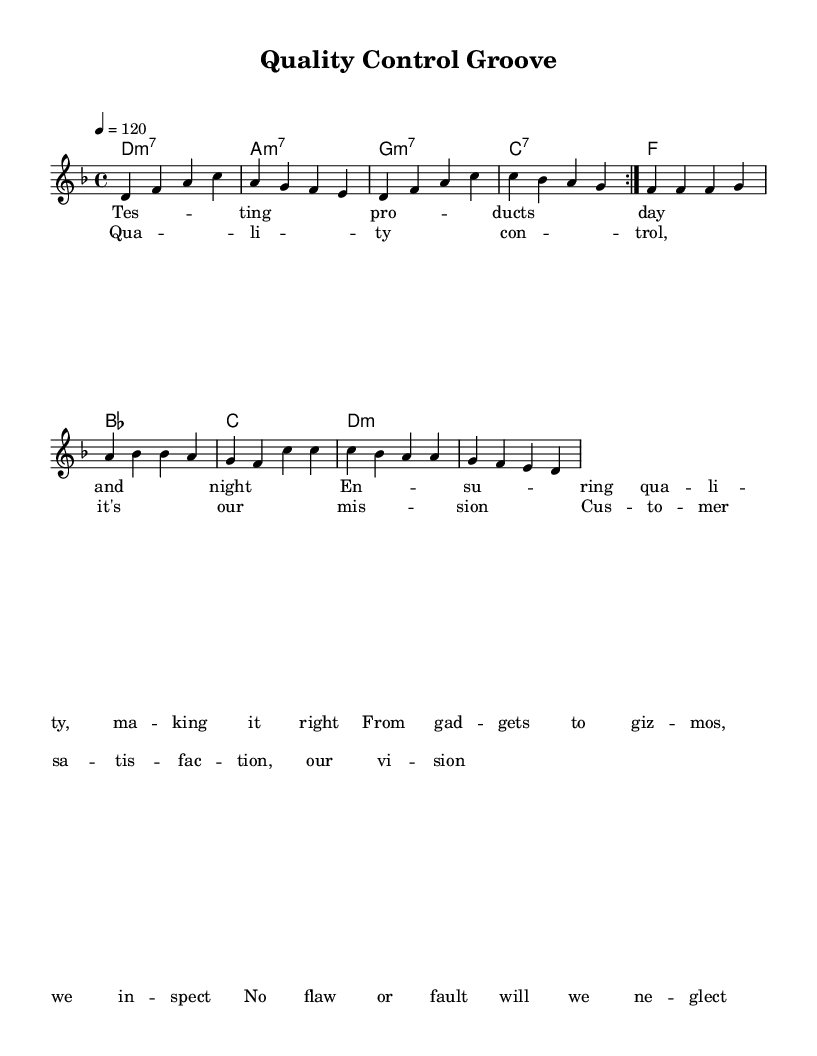What is the key signature of this music? The key signature is indicated at the beginning of the score. It shows two flats, which corresponds to D minor.
Answer: D minor What is the time signature of this piece? The time signature is shown at the beginning of the music staff. It is written as 4/4, indicating four beats per measure.
Answer: 4/4 What is the tempo marking for the piece? The tempo marking is located near the beginning of the score, which states 4 = 120, indicating that the quarter note gets 120 beats per minute.
Answer: 120 How many times is the melody repeated in the first section? The melody section includes a repeat sign marked at the start, indicating it is to be played twice before moving on.
Answer: 2 What type of chords are used in the harmony section? The harmony section shows a variety of chords, most notably minor seventh chords such as D minor and A minor, which are characteristic of fusion styles.
Answer: Minor seventh What is the primary theme of the lyrics? The lyrics describe the process of product testing and quality control, which emphasizes ensuring quality and customer satisfaction, evident throughout the verses and chorus.
Answer: Quality control In which genre context does this music fit best? The structure, tempo, and instrumentation suggest this piece fits in the genre of Electro-funk, as it incorporates electronic elements with funk rhythms.
Answer: Electro-funk 